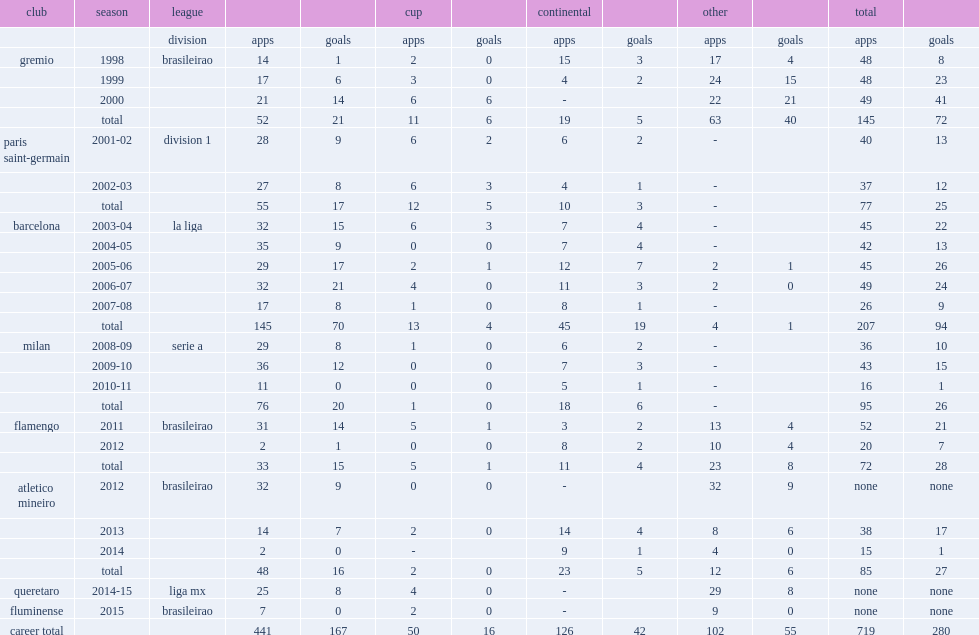Which club did ronaldinho play for in 2008-09? Milan. 